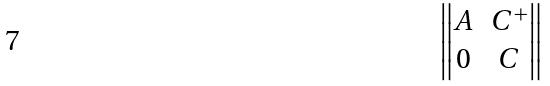<formula> <loc_0><loc_0><loc_500><loc_500>\begin{Vmatrix} A & C ^ { + } \\ 0 & C \end{Vmatrix}</formula> 